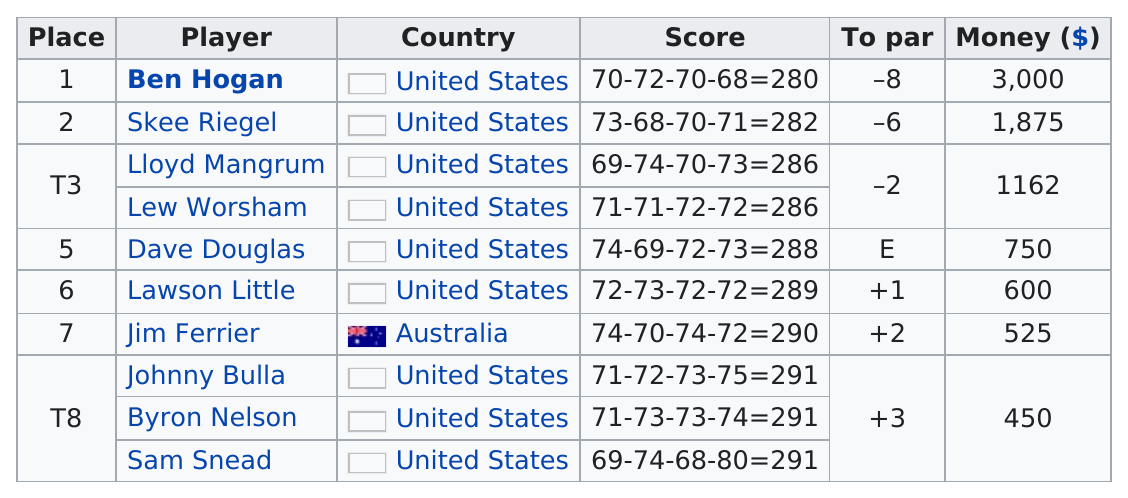Mention a couple of crucial points in this snapshot. The prize money difference between golf legends Ben Hogan and Sam Snead is 2,550. It is known that Lloyd Mangrum had the same score as Lew Worhsam. As of the open category, there is only one player from Australia. Dave Douglas placed above Lawson Little. The player who placed last was produced by the United States. 